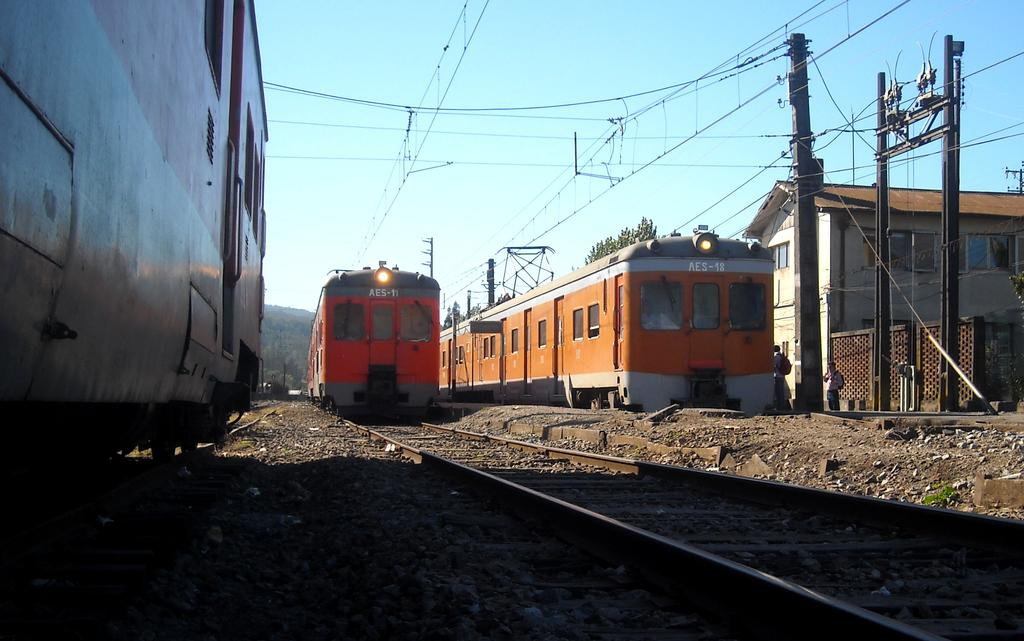How many trains are visible in the image? There are three trains in the image. What is the location of the trains in the image? The trains are on a track. What can be seen in the background of the image? There are wires, a house, trees, and the sky visible in the background of the image. What is the condition of the sky in the image? The sky is visible and clear in the background of the image. What type of friction can be seen between the trains and the track in the image? There is no indication of friction between the trains and the track in the image. What subject is being taught by the trains in the image? The image does not depict any teaching or educational activity involving the trains. 